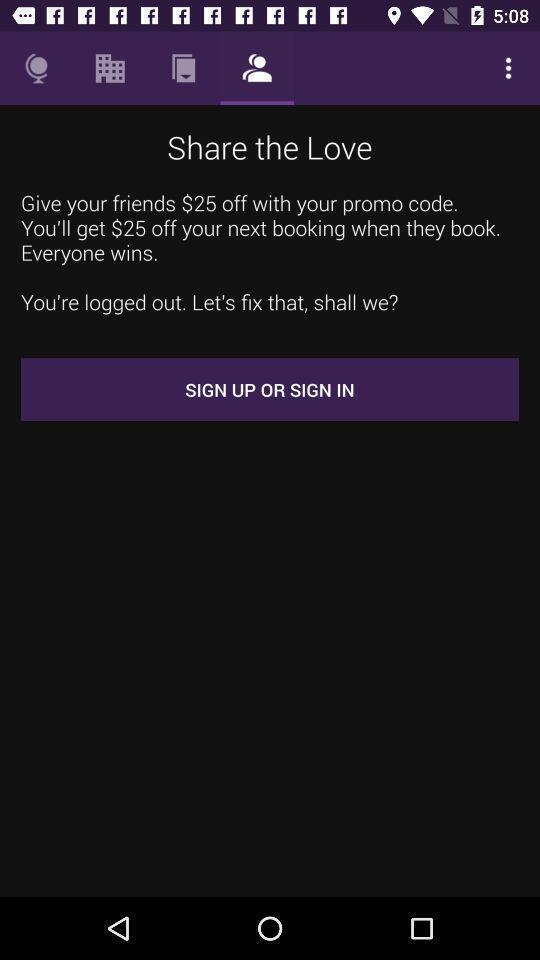Tell me about the visual elements in this screen capture. Sign up page of a booking app with some instructions. 